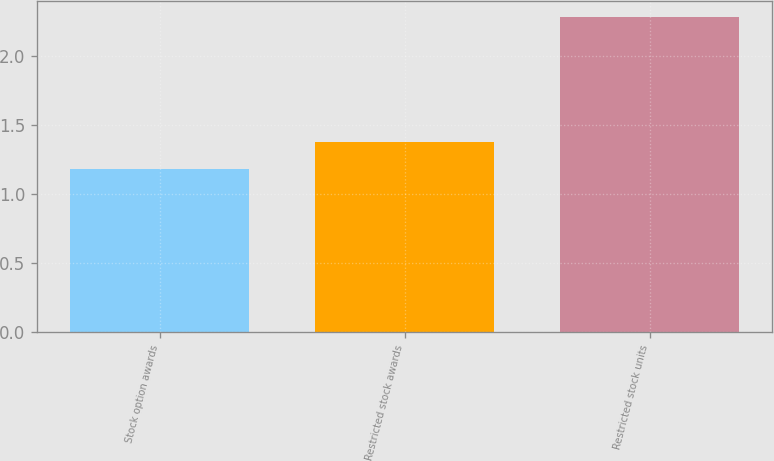<chart> <loc_0><loc_0><loc_500><loc_500><bar_chart><fcel>Stock option awards<fcel>Restricted stock awards<fcel>Restricted stock units<nl><fcel>1.18<fcel>1.38<fcel>2.28<nl></chart> 